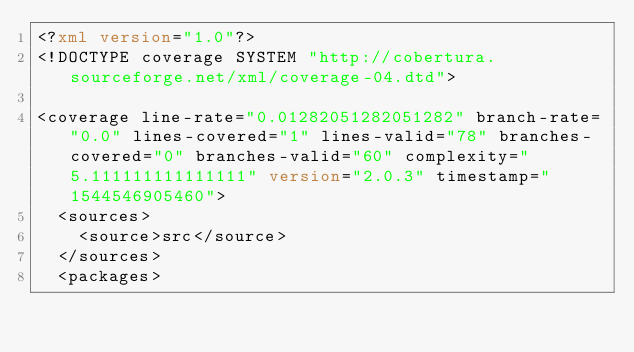Convert code to text. <code><loc_0><loc_0><loc_500><loc_500><_XML_><?xml version="1.0"?>
<!DOCTYPE coverage SYSTEM "http://cobertura.sourceforge.net/xml/coverage-04.dtd">

<coverage line-rate="0.01282051282051282" branch-rate="0.0" lines-covered="1" lines-valid="78" branches-covered="0" branches-valid="60" complexity="5.111111111111111" version="2.0.3" timestamp="1544546905460">
	<sources>
		<source>src</source>
	</sources>
	<packages></code> 